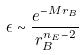<formula> <loc_0><loc_0><loc_500><loc_500>\epsilon \sim \frac { e ^ { - M r _ { B } } } { r _ { B } ^ { n _ { E } - 2 } }</formula> 